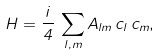<formula> <loc_0><loc_0><loc_500><loc_500>H = \frac { i } { 4 } \, \sum _ { l , m } A _ { l m } \, c _ { l } \, c _ { m } ,</formula> 